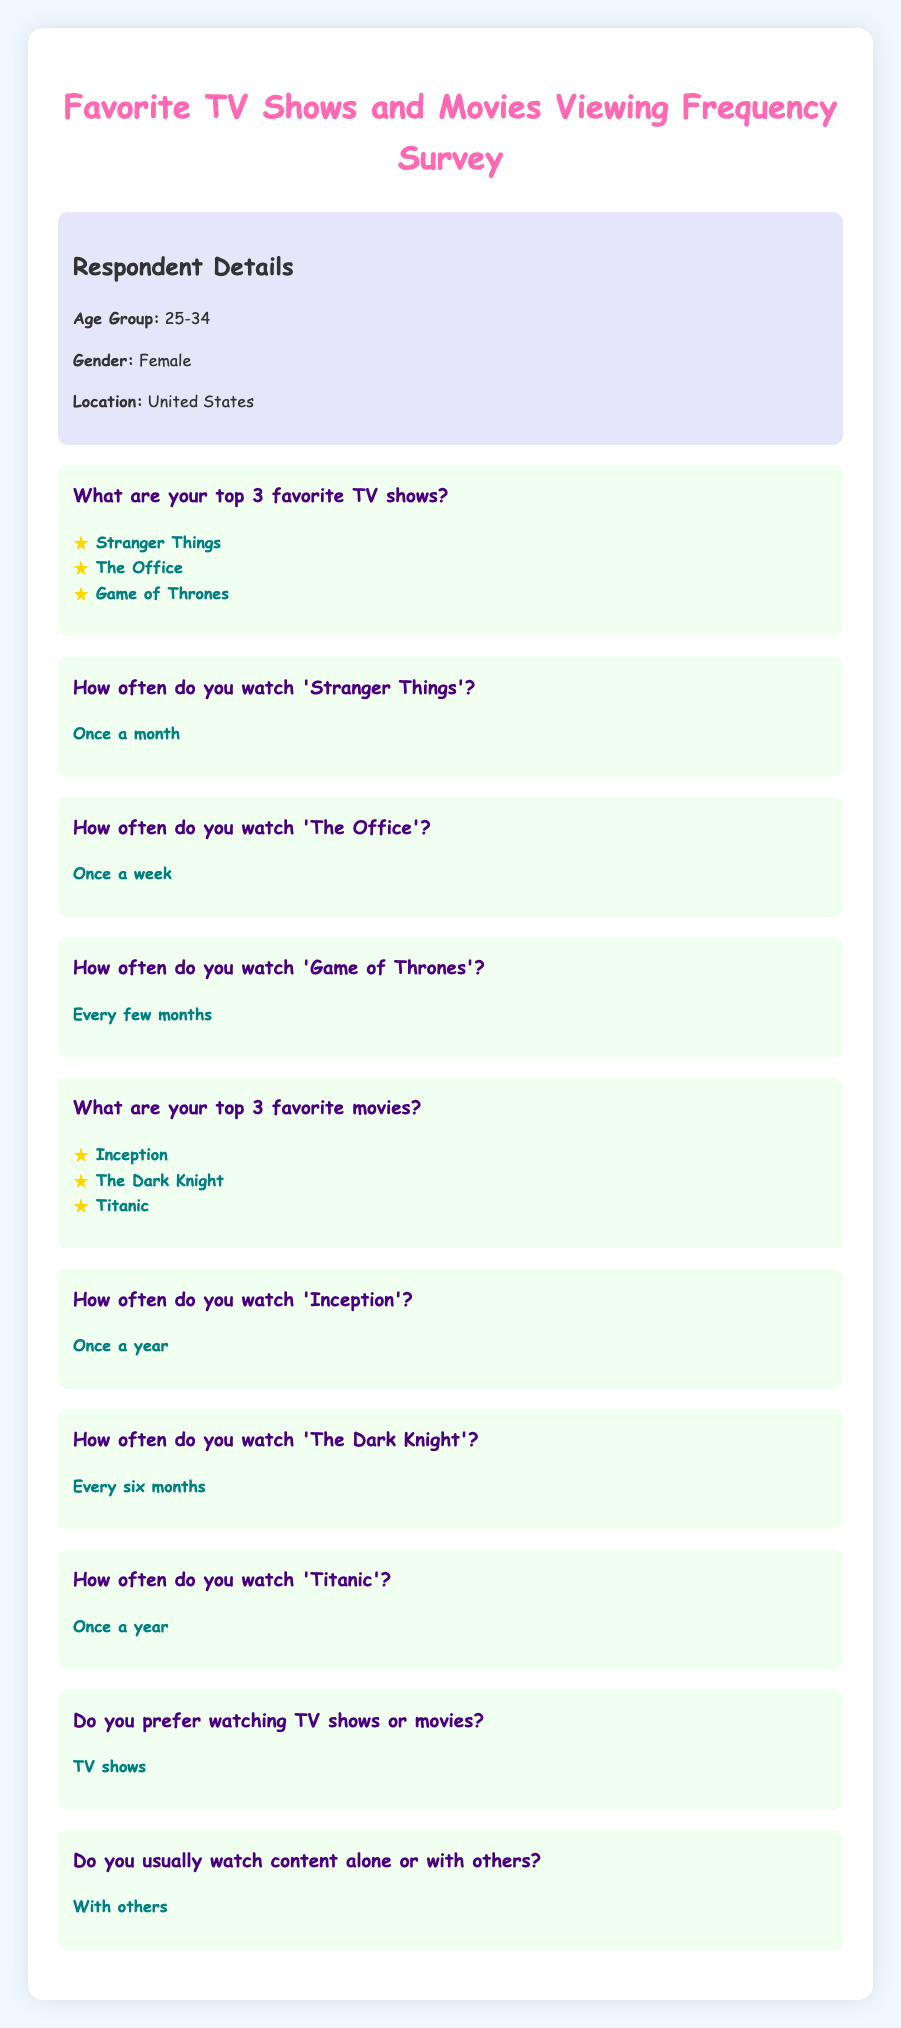What is the first favorite TV show listed? The document lists the favorite TV shows in a specific order, with "Stranger Things" as the first one mentioned.
Answer: Stranger Things How often does the respondent watch 'The Office'? The response indicates the frequency of watching 'The Office,' which is stated as "Once a week."
Answer: Once a week What is the age group of the respondent? The document specifies the age group of the respondent as part of their details, which is "25-34."
Answer: 25-34 Which favorite movie is watched every six months? The frequency for each favorite movie is detailed, and "The Dark Knight" is specifically noted as being watched every six months.
Answer: The Dark Knight Do they prefer watching TV shows or movies? The preference regarding media consumption is clearly stated in the response, indicating a choice between the two.
Answer: TV shows How many favorite movies does the respondent list? The document includes a section for favorite movies, clearly indicating that three titles are mentioned.
Answer: Three How often does the respondent watch 'Inception'? The watching frequency for 'Inception' is provided, and it is noted that it is watched "Once a year."
Answer: Once a year What type of viewing situation does the respondent prefer? The document asks about the social context of watching content, and the answer reflects their preference.
Answer: With others What are the top three favorite movies? The document lists specific titles under favorite movies, succinctly detailing the respondent's choices.
Answer: Inception, The Dark Knight, Titanic 